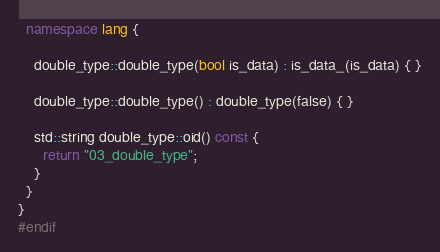<code> <loc_0><loc_0><loc_500><loc_500><_C++_>  namespace lang {

    double_type::double_type(bool is_data) : is_data_(is_data) { }

    double_type::double_type() : double_type(false) { }

    std::string double_type::oid() const {
      return "03_double_type";
    }
  }
}
#endif

</code> 